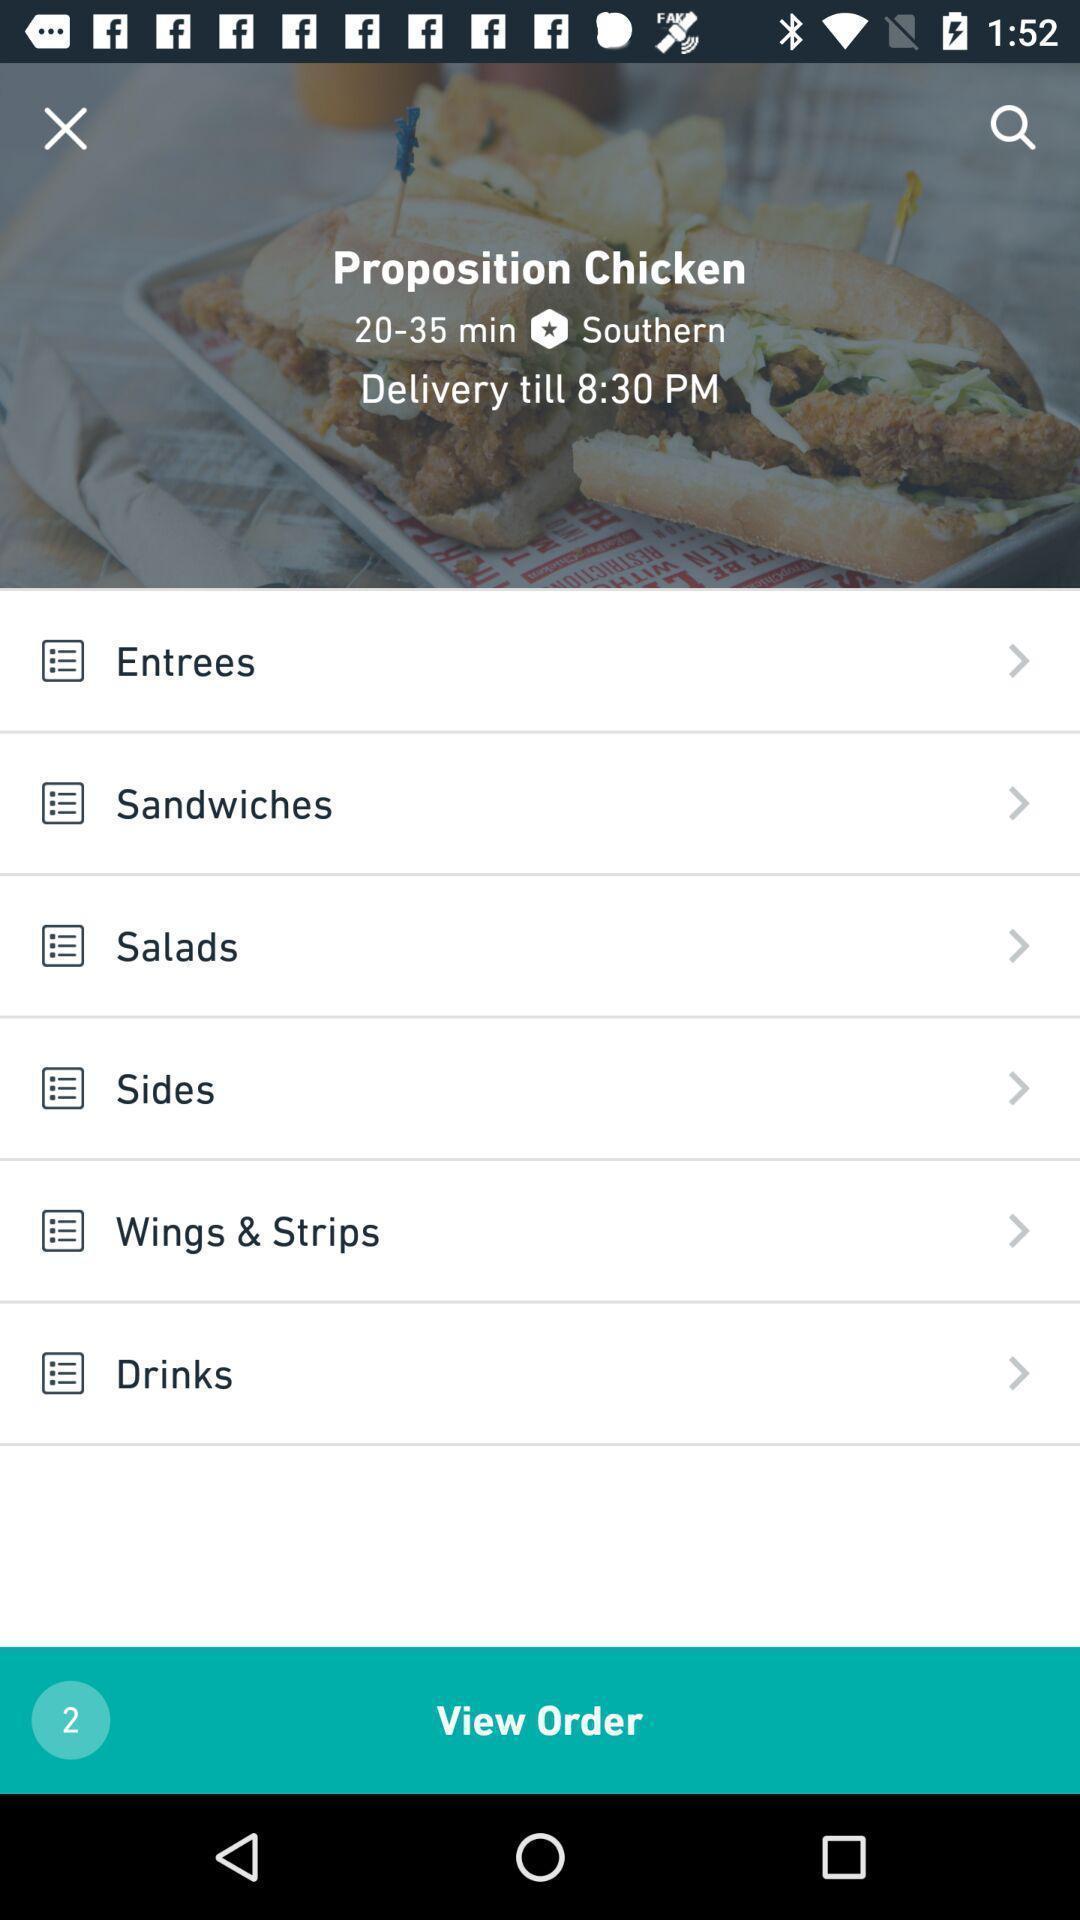Describe the content in this image. Screen shows view order page in food delivery app. 